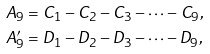<formula> <loc_0><loc_0><loc_500><loc_500>A _ { 9 } & = C _ { 1 } - C _ { 2 } - C _ { 3 } - \cdots - C _ { 9 } , \\ A _ { 9 } ^ { \prime } & = D _ { 1 } - D _ { 2 } - D _ { 3 } - \cdots - D _ { 9 } ,</formula> 